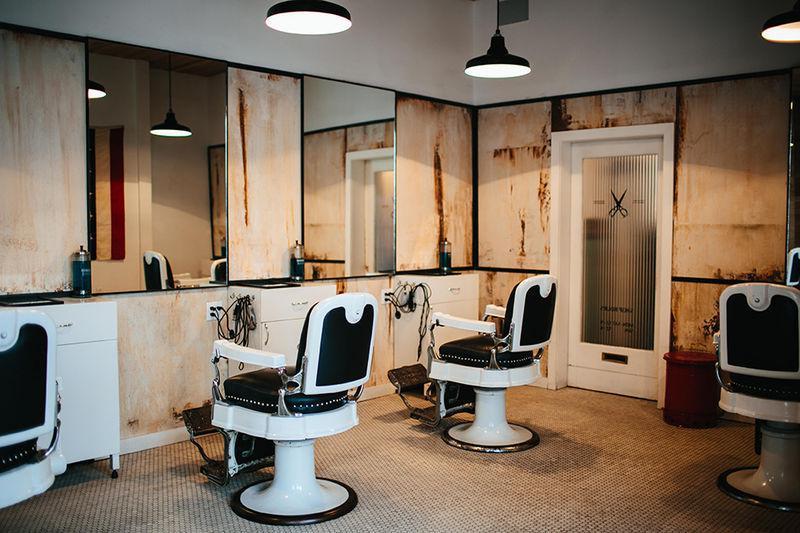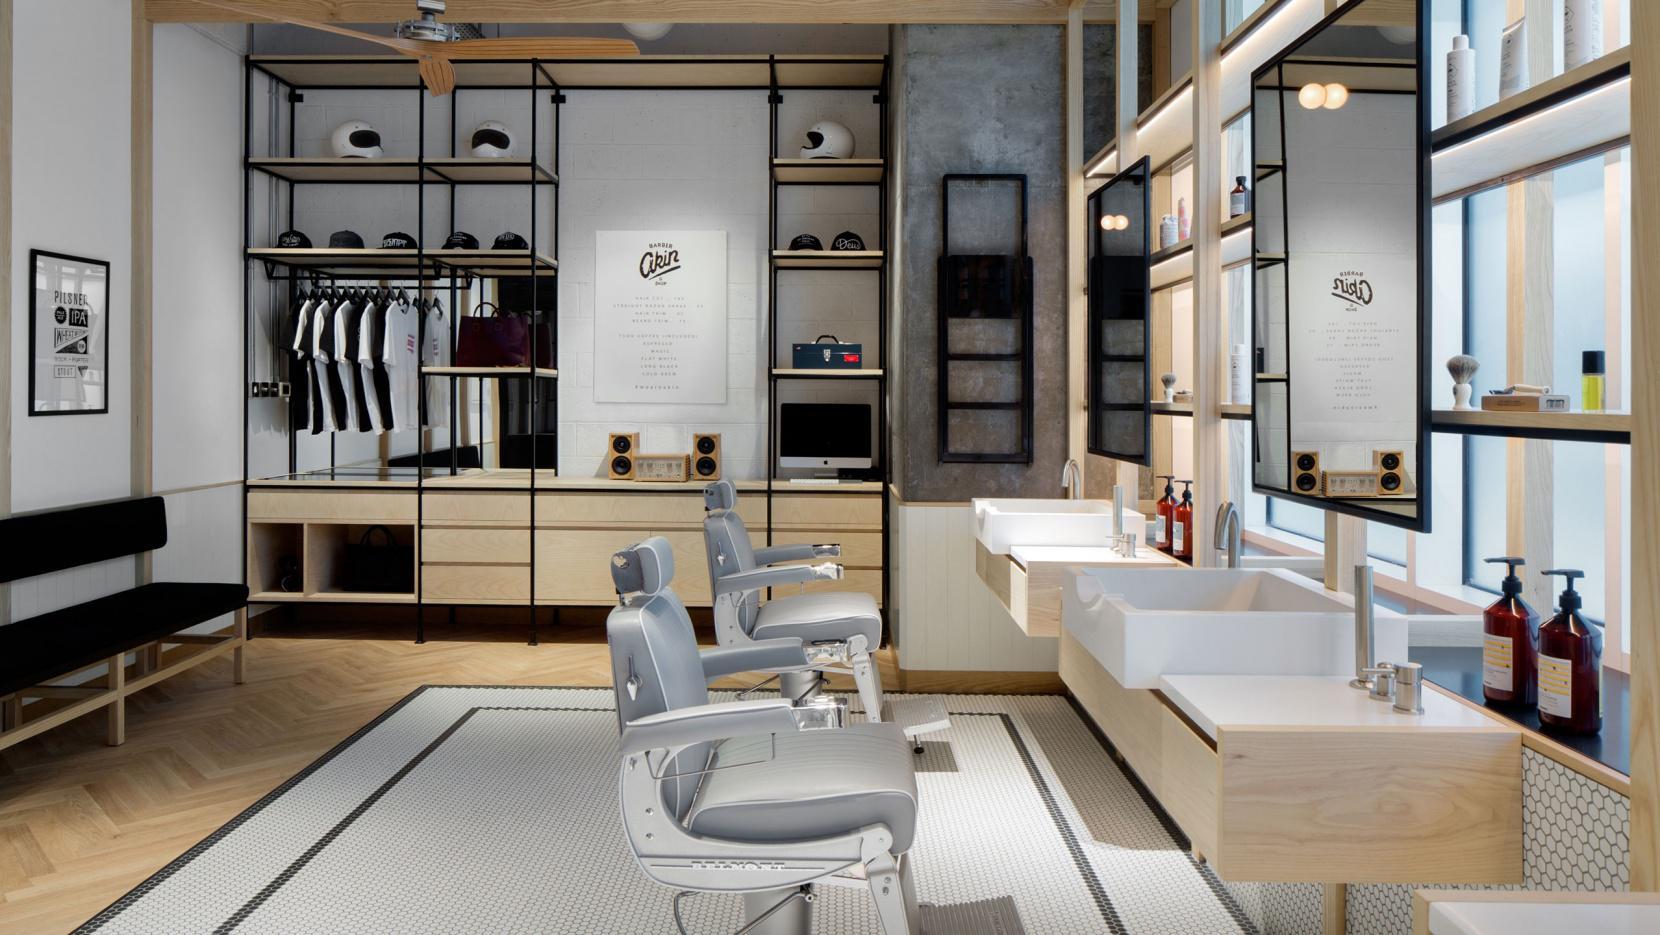The first image is the image on the left, the second image is the image on the right. Evaluate the accuracy of this statement regarding the images: "There are mirrors on the right wall of the room in the image on the right". Is it true? Answer yes or no. Yes. 